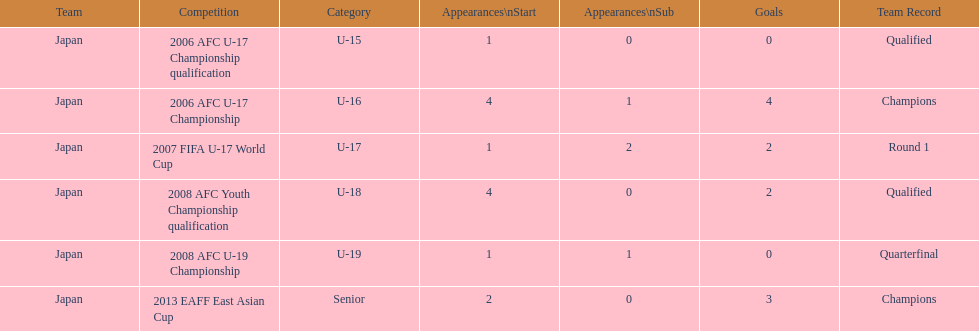What competitive event did japan take part in 2013? 2013 EAFF East Asian Cup. 